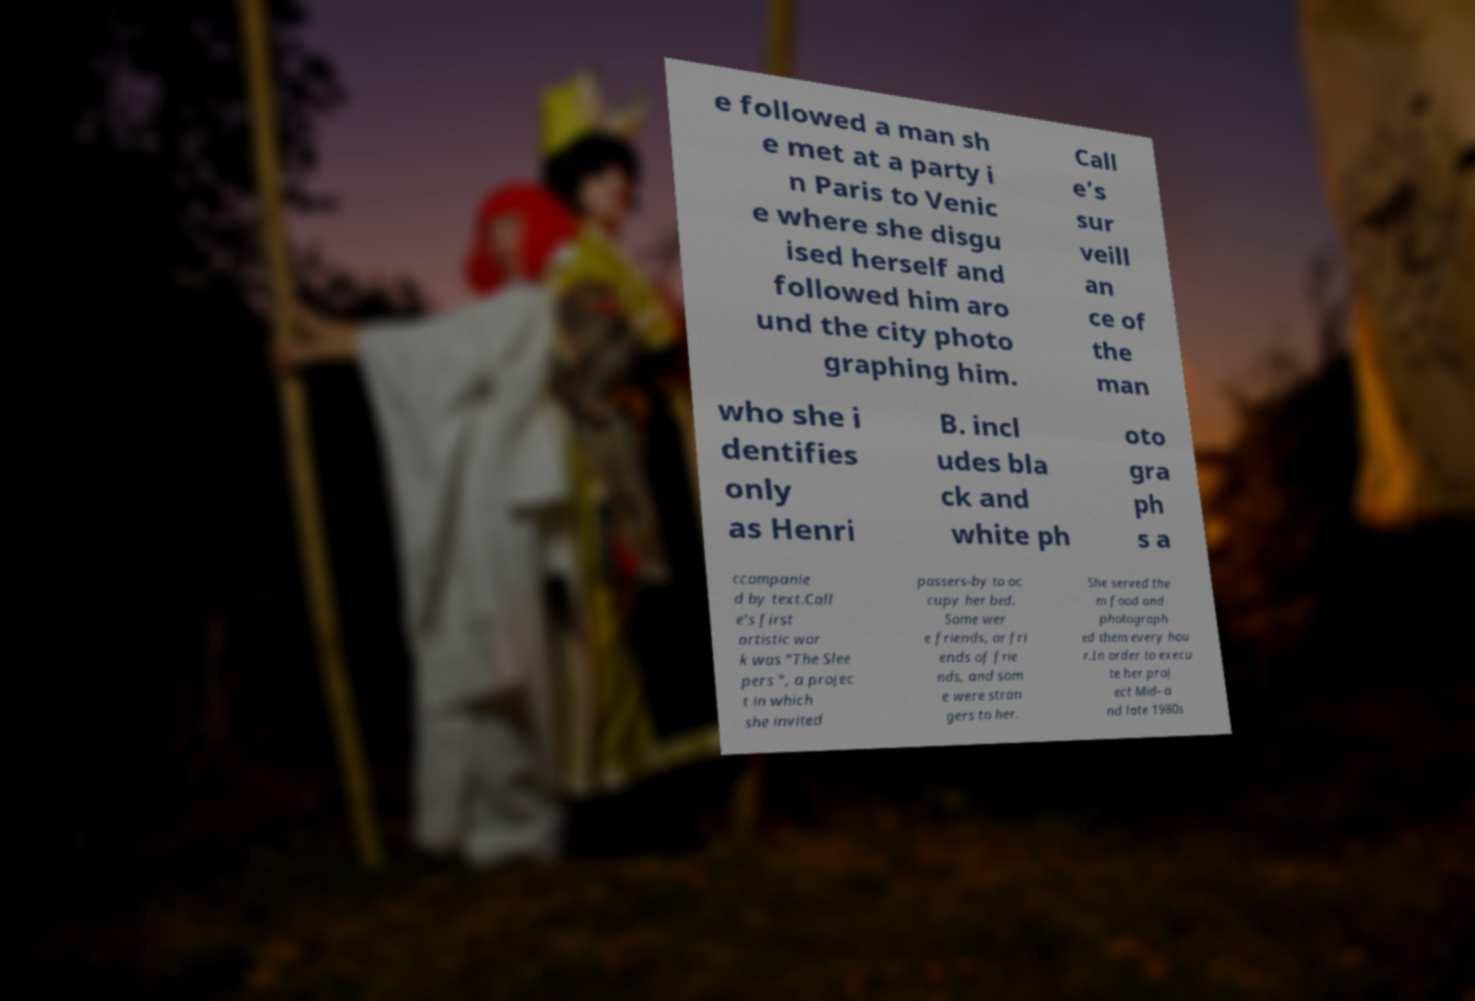Please identify and transcribe the text found in this image. e followed a man sh e met at a party i n Paris to Venic e where she disgu ised herself and followed him aro und the city photo graphing him. Call e’s sur veill an ce of the man who she i dentifies only as Henri B. incl udes bla ck and white ph oto gra ph s a ccompanie d by text.Call e's first artistic wor k was "The Slee pers ", a projec t in which she invited passers-by to oc cupy her bed. Some wer e friends, or fri ends of frie nds, and som e were stran gers to her. She served the m food and photograph ed them every hou r.In order to execu te her proj ect Mid- a nd late 1980s 